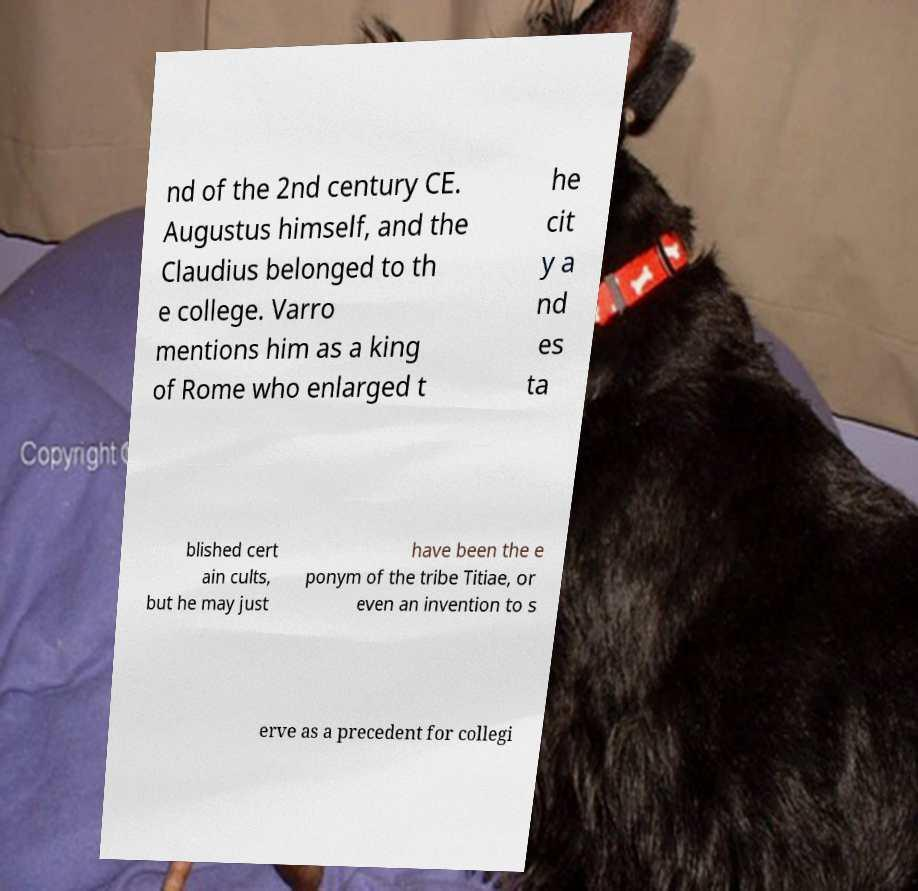What messages or text are displayed in this image? I need them in a readable, typed format. nd of the 2nd century CE. Augustus himself, and the Claudius belonged to th e college. Varro mentions him as a king of Rome who enlarged t he cit y a nd es ta blished cert ain cults, but he may just have been the e ponym of the tribe Titiae, or even an invention to s erve as a precedent for collegi 